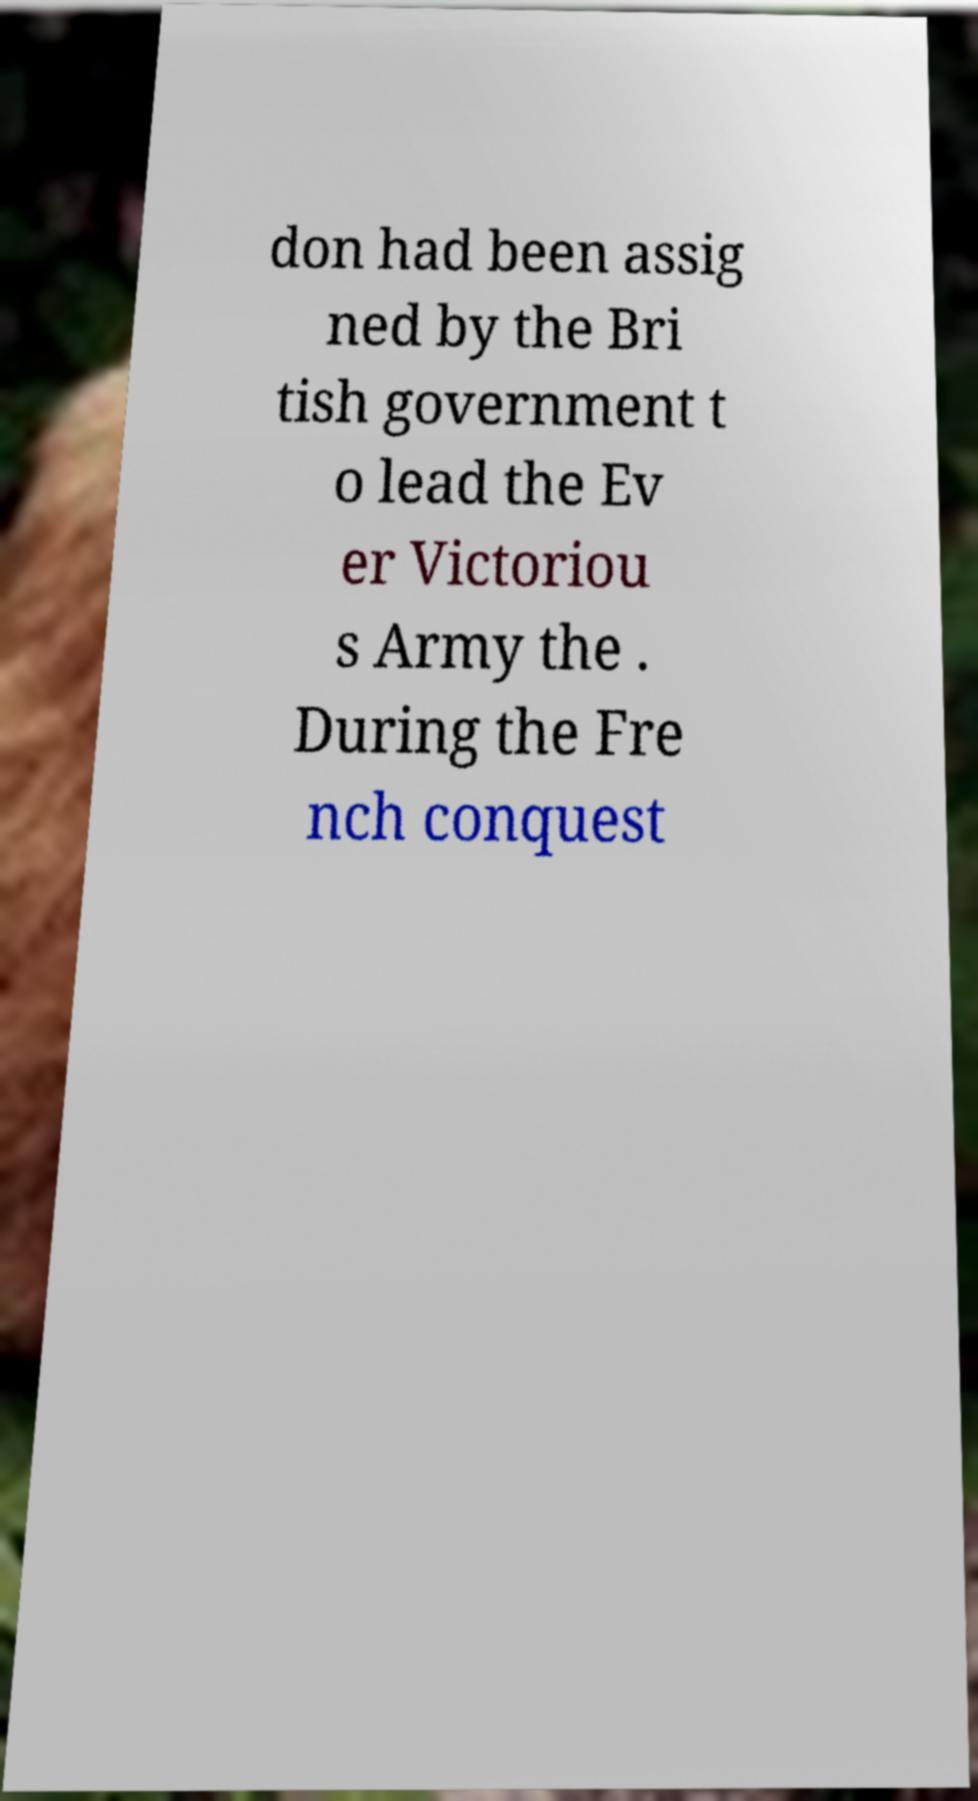What messages or text are displayed in this image? I need them in a readable, typed format. don had been assig ned by the Bri tish government t o lead the Ev er Victoriou s Army the . During the Fre nch conquest 